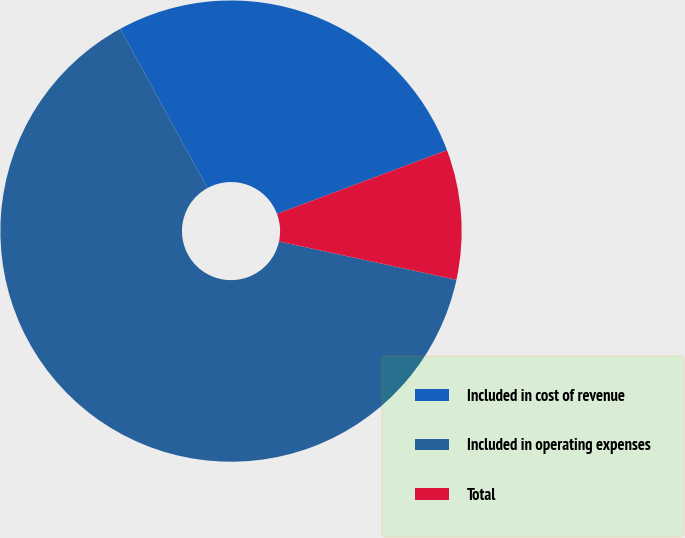Convert chart. <chart><loc_0><loc_0><loc_500><loc_500><pie_chart><fcel>Included in cost of revenue<fcel>Included in operating expenses<fcel>Total<nl><fcel>27.27%<fcel>63.64%<fcel>9.09%<nl></chart> 